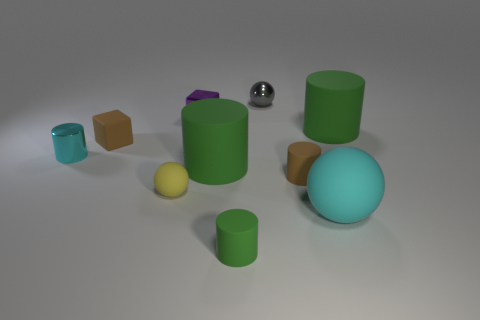Are there any other things that are made of the same material as the yellow ball?
Your answer should be very brief. Yes. Is there a tiny purple metal thing that is behind the big green rubber object in front of the rubber cylinder that is behind the matte cube?
Give a very brief answer. Yes. There is a sphere left of the tiny green rubber cylinder; what material is it?
Ensure brevity in your answer.  Rubber. How many tiny things are cyan spheres or cyan shiny cubes?
Ensure brevity in your answer.  0. Is the size of the green rubber thing that is in front of the cyan ball the same as the cyan ball?
Keep it short and to the point. No. How many other things are the same color as the small shiny ball?
Make the answer very short. 0. What material is the tiny gray sphere?
Your answer should be compact. Metal. There is a small thing that is both in front of the brown matte block and on the left side of the yellow object; what material is it made of?
Provide a short and direct response. Metal. How many things are either tiny cylinders that are to the right of the metallic ball or large green cylinders?
Your answer should be compact. 3. Is the color of the big sphere the same as the small matte sphere?
Your response must be concise. No. 